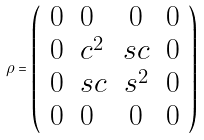Convert formula to latex. <formula><loc_0><loc_0><loc_500><loc_500>\rho = \left ( \begin{array} { c l c l } 0 & 0 & 0 & 0 \\ 0 & c ^ { 2 } & s c & 0 \\ 0 & s c & s ^ { 2 } & 0 \\ 0 & 0 & 0 & 0 \end{array} \right )</formula> 